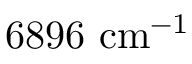Convert formula to latex. <formula><loc_0><loc_0><loc_500><loc_500>6 8 9 6 c m ^ { - 1 }</formula> 